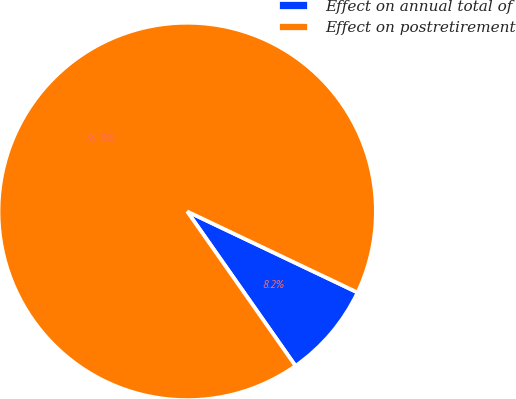<chart> <loc_0><loc_0><loc_500><loc_500><pie_chart><fcel>Effect on annual total of<fcel>Effect on postretirement<nl><fcel>8.2%<fcel>91.8%<nl></chart> 